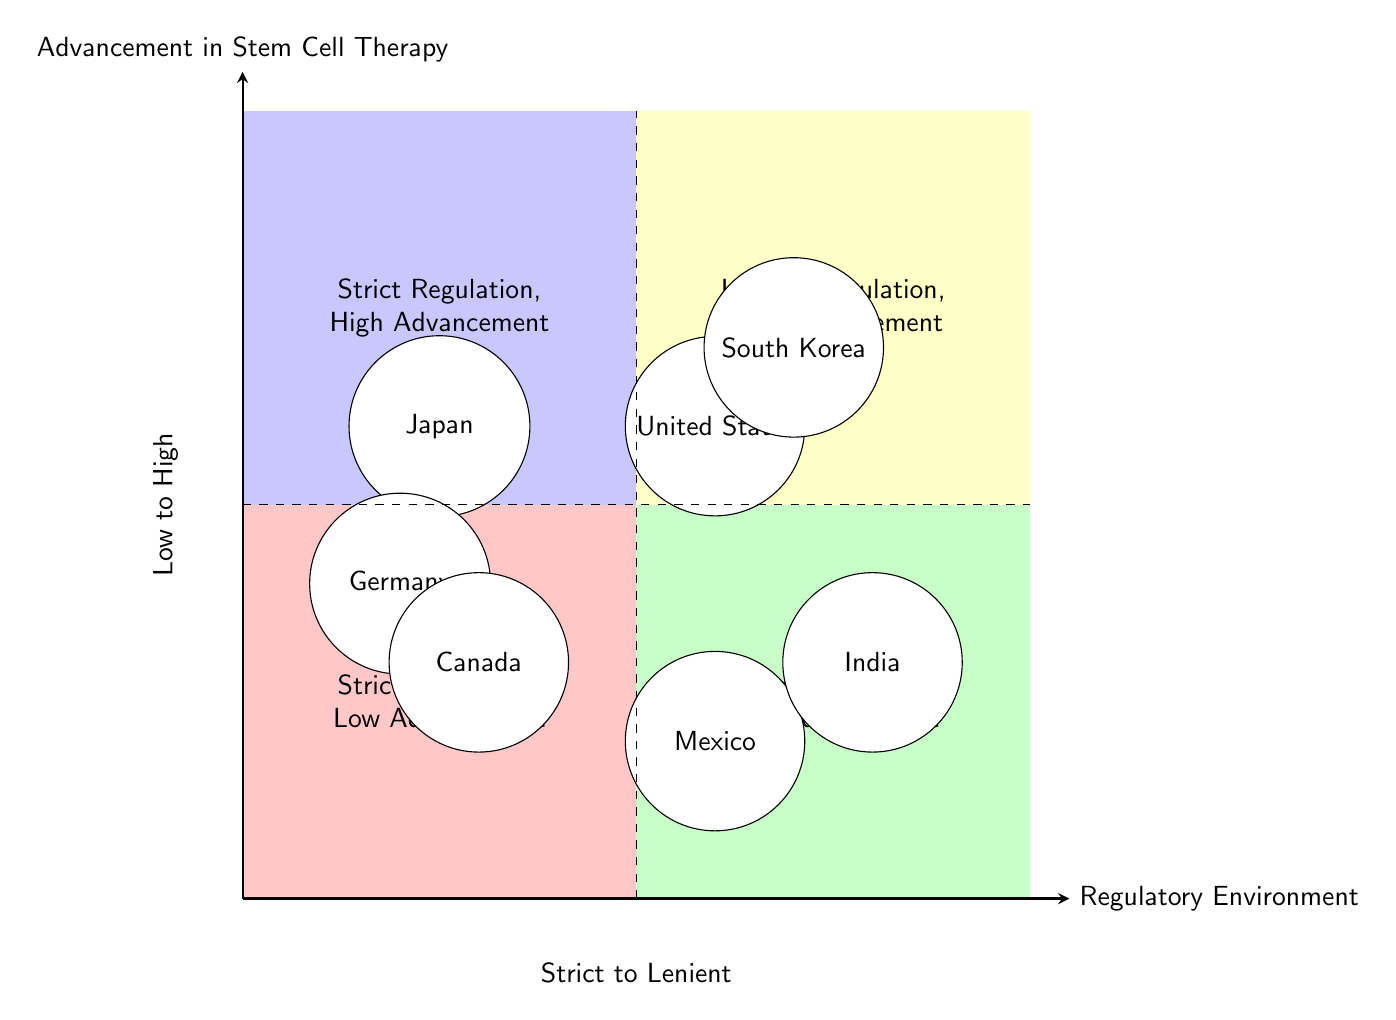What country is in the quadrant "Strict Regulation, High Advancement"? The diagram clearly places Japan in the "Strict Regulation, High Advancement" quadrant. By looking at the corresponding section, I can identify the name of the country represented in this quadrant.
Answer: Japan Which regulatory body oversees stem cell therapy in the United States? In the quadrant titled "Lenient Regulation, High Advancement," the United States is associated with the Food and Drug Administration (FDA). This information can be easily located in the specific section of the diagram dedicated to the U.S.
Answer: Food and Drug Administration (FDA) How many countries are positioned in the "Lenient Regulation, Low Advancement" quadrant? The quadrant labeled "Lenient Regulation, Low Advancement" contains two countries: Mexico and India. I can visually count the countries represented in this quadrant to find the total.
Answer: 2 What are the advancements in stem cell therapy for Germany? In the "Strict Regulation, Low Advancement" quadrant, Germany's entry specifies "Limited progress due to stringent regulations, predominantly in experimental phases". This information allows me to extract the advancements listed for Germany.
Answer: Limited progress due to stringent regulations, predominantly in experimental phases Which country has significant investments in stem cell research? South Korea is placed in the "Lenient Regulation, High Advancement" quadrant and is described as having "Significant investments in stem cell research." This detail is specifically mentioned in the relevant part of the diagram focused on South Korea.
Answer: South Korea What does the "General Health Law" refer to? The "General Health Law" is the key regulation for Mexico, which falls within the "Lenient Regulation, Low Advancement" quadrant. This law is directly mentioned in the description for that country's entry in the diagram.
Answer: General Health Law Which quadrant contains Japan and South Korea? Japan is located in the "Strict Regulation, High Advancement" quadrant while South Korea is in the "Lenient Regulation, High Advancement" quadrant. By identifying the positions of these countries, I can ascertain which quadrants they inhabit.
Answer: Q1 and Q2 